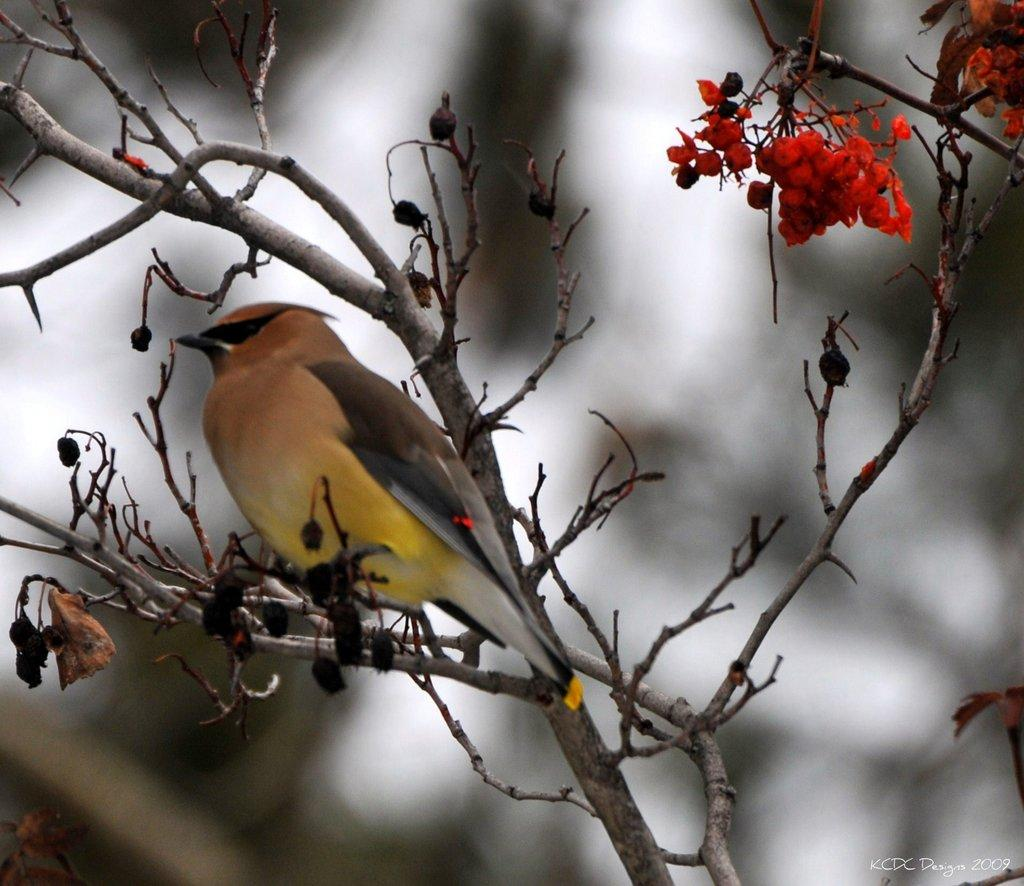What is on the tree branch in the image? There is a bird on a tree branch in the image. What can be seen on the tree besides the bird? The tree has fruits in the image. Can you describe the background of the image? The background is blurred in the image. What type of band is playing in the background of the image? There is no band present in the image; the background is blurred. 